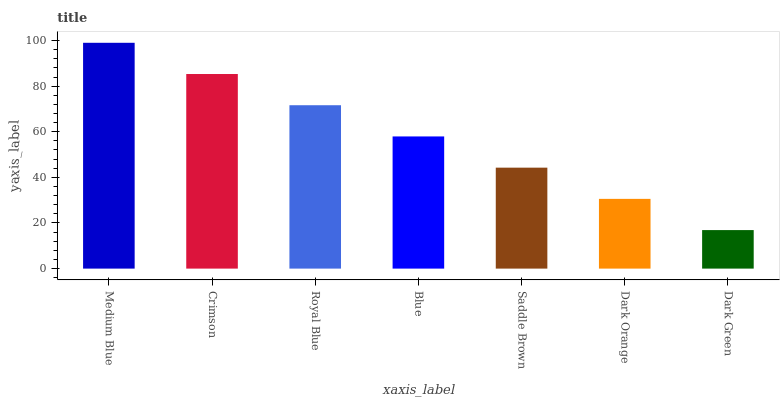Is Dark Green the minimum?
Answer yes or no. Yes. Is Medium Blue the maximum?
Answer yes or no. Yes. Is Crimson the minimum?
Answer yes or no. No. Is Crimson the maximum?
Answer yes or no. No. Is Medium Blue greater than Crimson?
Answer yes or no. Yes. Is Crimson less than Medium Blue?
Answer yes or no. Yes. Is Crimson greater than Medium Blue?
Answer yes or no. No. Is Medium Blue less than Crimson?
Answer yes or no. No. Is Blue the high median?
Answer yes or no. Yes. Is Blue the low median?
Answer yes or no. Yes. Is Dark Green the high median?
Answer yes or no. No. Is Saddle Brown the low median?
Answer yes or no. No. 